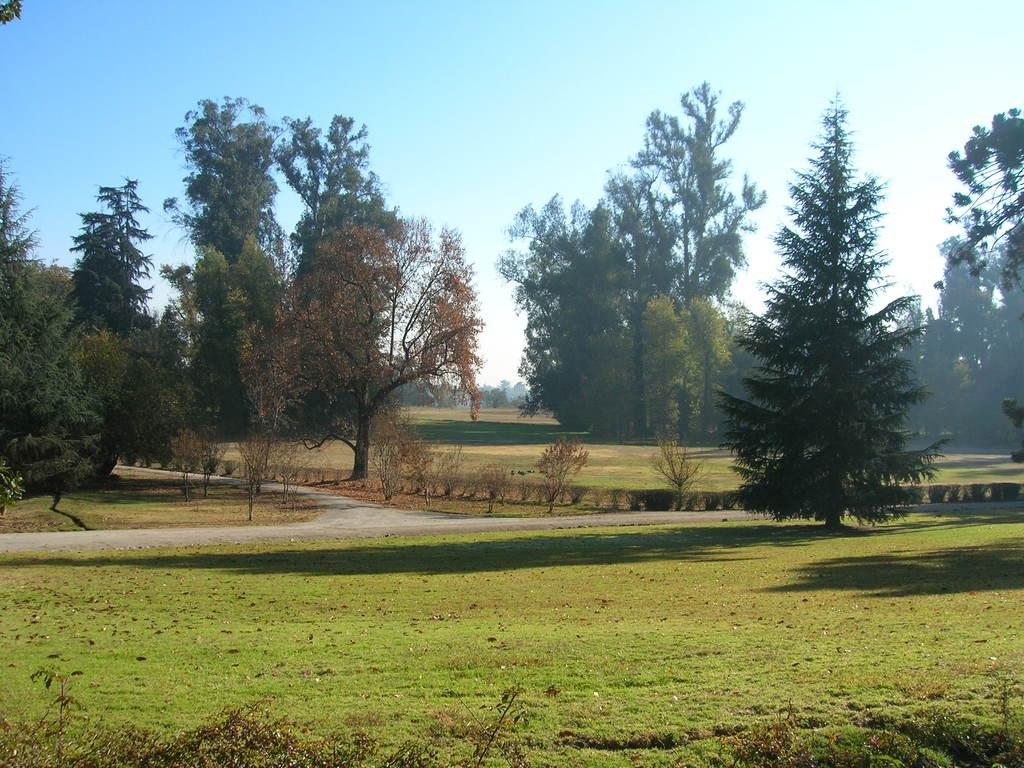Where was the picture taken? The picture was clicked outside. What can be seen in the foreground of the image? There is green grass in the foreground of the image. What is present in the center of the image? There are plants and trees in the center of the image. What is visible in the background of the image? There is a sky visible in the background of the image. What type of coil can be seen in the image? There is no coil present in the image. How does the throat of the plant appear in the image? There are no visible throats of plants in the image, as plants do not have throats. 